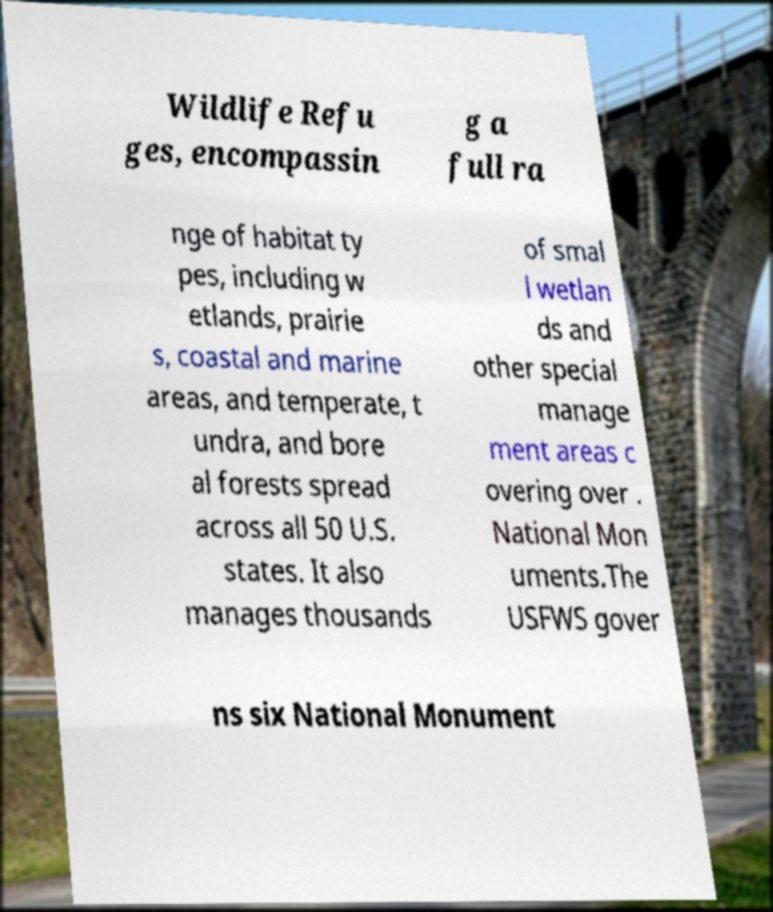Could you extract and type out the text from this image? Wildlife Refu ges, encompassin g a full ra nge of habitat ty pes, including w etlands, prairie s, coastal and marine areas, and temperate, t undra, and bore al forests spread across all 50 U.S. states. It also manages thousands of smal l wetlan ds and other special manage ment areas c overing over . National Mon uments.The USFWS gover ns six National Monument 